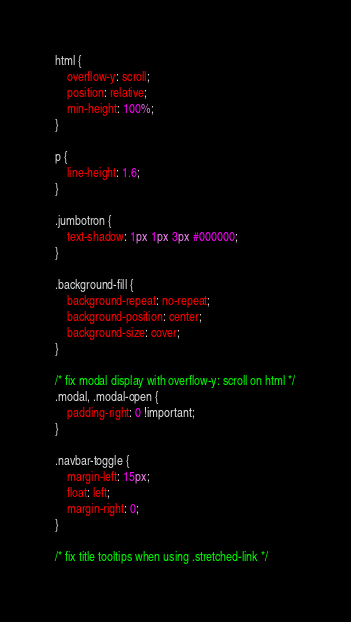<code> <loc_0><loc_0><loc_500><loc_500><_CSS_>html {
    overflow-y: scroll;
    position: relative;
    min-height: 100%;
}

p {
    line-height: 1.6;
}

.jumbotron {
    text-shadow: 1px 1px 3px #000000;
}

.background-fill {
    background-repeat: no-repeat;
    background-position: center;
    background-size: cover;
}

/* fix modal display with overflow-y: scroll on html */
.modal, .modal-open {
    padding-right: 0 !important;
}

.navbar-toggle {
    margin-left: 15px;
    float: left;
    margin-right: 0;
}

/* fix title tooltips when using .stretched-link */</code> 